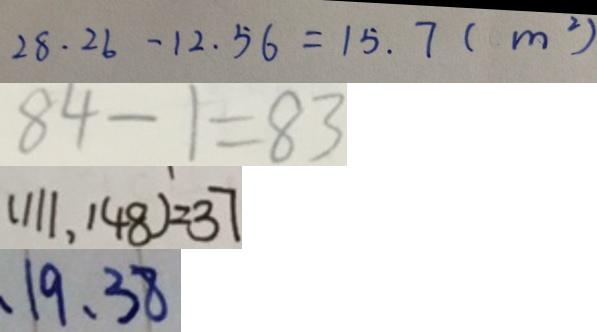Convert formula to latex. <formula><loc_0><loc_0><loc_500><loc_500>2 8 . 2 6 - 1 2 . 5 6 = 1 5 . 7 ( m ^ { 2 } ) 
 8 4 - 1 = 8 3 
 ( 1 1 1 , 1 4 8 ) = 3 7 
 、 1 9 、 3 8</formula> 